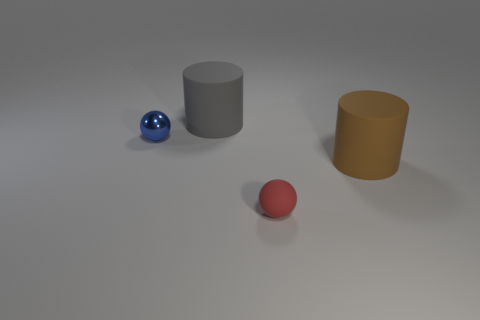Are there any other things that have the same material as the blue object?
Give a very brief answer. No. Is there a blue metal ball that has the same size as the matte ball?
Provide a short and direct response. Yes. There is a blue thing that is the same shape as the small red rubber thing; what is it made of?
Offer a very short reply. Metal. The red rubber thing that is the same size as the shiny ball is what shape?
Provide a short and direct response. Sphere. Are there any big gray matte things of the same shape as the small red rubber thing?
Offer a terse response. No. The big matte object that is to the left of the large brown cylinder in front of the tiny blue metallic object is what shape?
Your response must be concise. Cylinder. The blue metallic thing has what shape?
Keep it short and to the point. Sphere. What material is the large cylinder left of the big matte cylinder in front of the big thing to the left of the red thing?
Give a very brief answer. Rubber. What number of other objects are there of the same material as the tiny red ball?
Ensure brevity in your answer.  2. There is a large cylinder behind the brown rubber cylinder; how many blue balls are in front of it?
Keep it short and to the point. 1. 